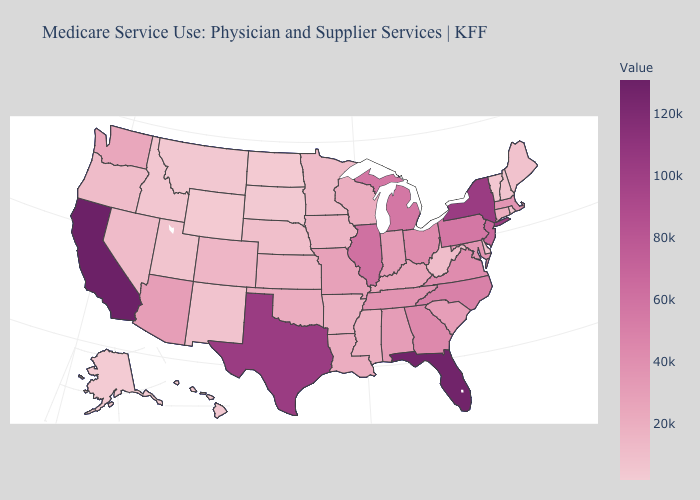Which states have the lowest value in the USA?
Write a very short answer. Alaska. Among the states that border Mississippi , which have the lowest value?
Quick response, please. Arkansas. Does Alaska have the lowest value in the USA?
Give a very brief answer. Yes. Does Alaska have the lowest value in the USA?
Keep it brief. Yes. Among the states that border Arizona , which have the lowest value?
Quick response, please. Utah. Does the map have missing data?
Write a very short answer. No. 